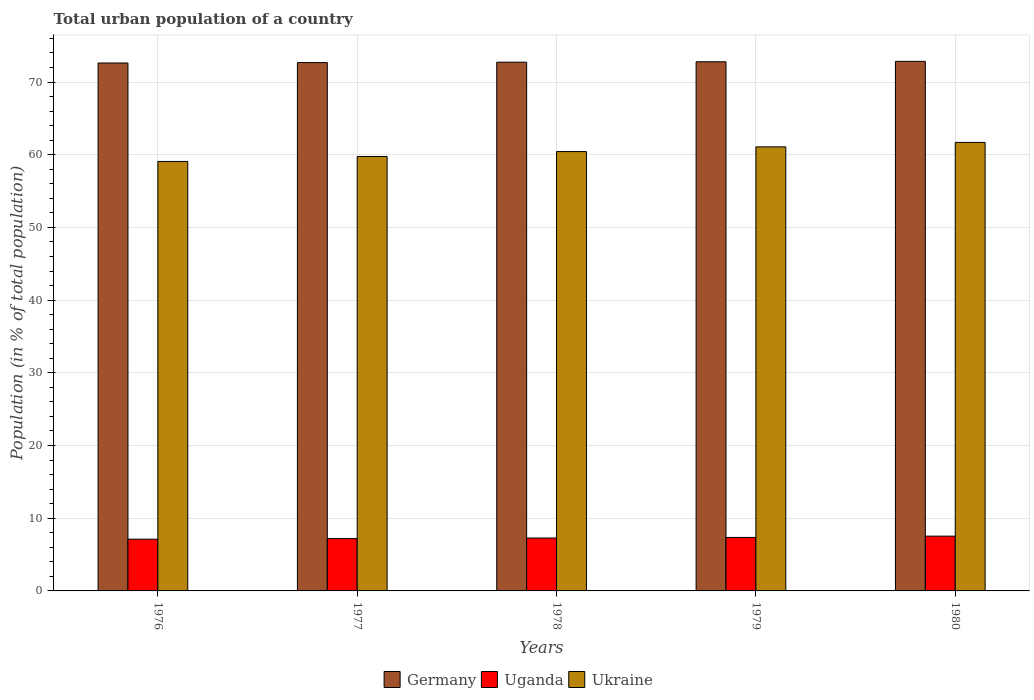How many different coloured bars are there?
Provide a succinct answer. 3. Are the number of bars per tick equal to the number of legend labels?
Your answer should be very brief. Yes. Are the number of bars on each tick of the X-axis equal?
Ensure brevity in your answer.  Yes. How many bars are there on the 2nd tick from the right?
Offer a very short reply. 3. What is the label of the 1st group of bars from the left?
Make the answer very short. 1976. In how many cases, is the number of bars for a given year not equal to the number of legend labels?
Give a very brief answer. 0. What is the urban population in Ukraine in 1977?
Offer a very short reply. 59.76. Across all years, what is the maximum urban population in Uganda?
Offer a terse response. 7.53. Across all years, what is the minimum urban population in Ukraine?
Your answer should be compact. 59.08. In which year was the urban population in Ukraine maximum?
Make the answer very short. 1980. In which year was the urban population in Uganda minimum?
Provide a short and direct response. 1976. What is the total urban population in Uganda in the graph?
Provide a succinct answer. 36.48. What is the difference between the urban population in Ukraine in 1977 and that in 1978?
Keep it short and to the point. -0.68. What is the difference between the urban population in Ukraine in 1977 and the urban population in Germany in 1979?
Offer a very short reply. -13.03. What is the average urban population in Uganda per year?
Provide a succinct answer. 7.3. In the year 1977, what is the difference between the urban population in Uganda and urban population in Germany?
Give a very brief answer. -65.48. What is the ratio of the urban population in Ukraine in 1978 to that in 1979?
Give a very brief answer. 0.99. Is the urban population in Uganda in 1979 less than that in 1980?
Provide a succinct answer. Yes. Is the difference between the urban population in Uganda in 1978 and 1979 greater than the difference between the urban population in Germany in 1978 and 1979?
Your answer should be compact. No. What is the difference between the highest and the second highest urban population in Ukraine?
Provide a succinct answer. 0.61. What is the difference between the highest and the lowest urban population in Germany?
Keep it short and to the point. 0.23. In how many years, is the urban population in Ukraine greater than the average urban population in Ukraine taken over all years?
Provide a succinct answer. 3. Is the sum of the urban population in Ukraine in 1977 and 1980 greater than the maximum urban population in Germany across all years?
Your answer should be very brief. Yes. What does the 1st bar from the left in 1977 represents?
Provide a succinct answer. Germany. What does the 1st bar from the right in 1977 represents?
Give a very brief answer. Ukraine. Is it the case that in every year, the sum of the urban population in Uganda and urban population in Germany is greater than the urban population in Ukraine?
Offer a terse response. Yes. How many bars are there?
Provide a succinct answer. 15. What is the difference between two consecutive major ticks on the Y-axis?
Make the answer very short. 10. Are the values on the major ticks of Y-axis written in scientific E-notation?
Your answer should be compact. No. Does the graph contain any zero values?
Offer a terse response. No. Does the graph contain grids?
Your answer should be compact. Yes. Where does the legend appear in the graph?
Your answer should be very brief. Bottom center. How are the legend labels stacked?
Offer a terse response. Horizontal. What is the title of the graph?
Keep it short and to the point. Total urban population of a country. Does "Qatar" appear as one of the legend labels in the graph?
Give a very brief answer. No. What is the label or title of the Y-axis?
Ensure brevity in your answer.  Population (in % of total population). What is the Population (in % of total population) in Germany in 1976?
Your answer should be very brief. 72.62. What is the Population (in % of total population) of Uganda in 1976?
Provide a short and direct response. 7.12. What is the Population (in % of total population) of Ukraine in 1976?
Ensure brevity in your answer.  59.08. What is the Population (in % of total population) in Germany in 1977?
Provide a short and direct response. 72.67. What is the Population (in % of total population) in Uganda in 1977?
Offer a terse response. 7.2. What is the Population (in % of total population) in Ukraine in 1977?
Your answer should be compact. 59.76. What is the Population (in % of total population) of Germany in 1978?
Your answer should be very brief. 72.73. What is the Population (in % of total population) in Uganda in 1978?
Keep it short and to the point. 7.28. What is the Population (in % of total population) of Ukraine in 1978?
Keep it short and to the point. 60.43. What is the Population (in % of total population) in Germany in 1979?
Offer a terse response. 72.79. What is the Population (in % of total population) of Uganda in 1979?
Keep it short and to the point. 7.36. What is the Population (in % of total population) of Ukraine in 1979?
Your answer should be compact. 61.08. What is the Population (in % of total population) of Germany in 1980?
Provide a short and direct response. 72.84. What is the Population (in % of total population) of Uganda in 1980?
Make the answer very short. 7.53. What is the Population (in % of total population) of Ukraine in 1980?
Give a very brief answer. 61.69. Across all years, what is the maximum Population (in % of total population) in Germany?
Provide a succinct answer. 72.84. Across all years, what is the maximum Population (in % of total population) of Uganda?
Make the answer very short. 7.53. Across all years, what is the maximum Population (in % of total population) of Ukraine?
Make the answer very short. 61.69. Across all years, what is the minimum Population (in % of total population) of Germany?
Ensure brevity in your answer.  72.62. Across all years, what is the minimum Population (in % of total population) in Uganda?
Your answer should be compact. 7.12. Across all years, what is the minimum Population (in % of total population) of Ukraine?
Keep it short and to the point. 59.08. What is the total Population (in % of total population) of Germany in the graph?
Your response must be concise. 363.65. What is the total Population (in % of total population) in Uganda in the graph?
Offer a terse response. 36.48. What is the total Population (in % of total population) in Ukraine in the graph?
Keep it short and to the point. 302.04. What is the difference between the Population (in % of total population) of Germany in 1976 and that in 1977?
Offer a terse response. -0.06. What is the difference between the Population (in % of total population) in Uganda in 1976 and that in 1977?
Offer a terse response. -0.08. What is the difference between the Population (in % of total population) of Ukraine in 1976 and that in 1977?
Offer a terse response. -0.68. What is the difference between the Population (in % of total population) in Germany in 1976 and that in 1978?
Offer a terse response. -0.11. What is the difference between the Population (in % of total population) in Uganda in 1976 and that in 1978?
Offer a very short reply. -0.16. What is the difference between the Population (in % of total population) of Ukraine in 1976 and that in 1978?
Provide a short and direct response. -1.36. What is the difference between the Population (in % of total population) in Germany in 1976 and that in 1979?
Offer a terse response. -0.17. What is the difference between the Population (in % of total population) of Uganda in 1976 and that in 1979?
Keep it short and to the point. -0.24. What is the difference between the Population (in % of total population) of Ukraine in 1976 and that in 1979?
Provide a short and direct response. -2.01. What is the difference between the Population (in % of total population) of Germany in 1976 and that in 1980?
Your answer should be compact. -0.23. What is the difference between the Population (in % of total population) in Uganda in 1976 and that in 1980?
Provide a short and direct response. -0.42. What is the difference between the Population (in % of total population) of Ukraine in 1976 and that in 1980?
Keep it short and to the point. -2.62. What is the difference between the Population (in % of total population) in Germany in 1977 and that in 1978?
Your answer should be very brief. -0.06. What is the difference between the Population (in % of total population) in Uganda in 1977 and that in 1978?
Give a very brief answer. -0.08. What is the difference between the Population (in % of total population) of Ukraine in 1977 and that in 1978?
Your answer should be compact. -0.68. What is the difference between the Population (in % of total population) in Germany in 1977 and that in 1979?
Your response must be concise. -0.11. What is the difference between the Population (in % of total population) of Uganda in 1977 and that in 1979?
Offer a very short reply. -0.16. What is the difference between the Population (in % of total population) in Ukraine in 1977 and that in 1979?
Keep it short and to the point. -1.32. What is the difference between the Population (in % of total population) of Germany in 1977 and that in 1980?
Provide a succinct answer. -0.17. What is the difference between the Population (in % of total population) in Uganda in 1977 and that in 1980?
Provide a short and direct response. -0.34. What is the difference between the Population (in % of total population) in Ukraine in 1977 and that in 1980?
Provide a short and direct response. -1.94. What is the difference between the Population (in % of total population) in Germany in 1978 and that in 1979?
Offer a terse response. -0.06. What is the difference between the Population (in % of total population) in Uganda in 1978 and that in 1979?
Keep it short and to the point. -0.08. What is the difference between the Population (in % of total population) in Ukraine in 1978 and that in 1979?
Your answer should be very brief. -0.65. What is the difference between the Population (in % of total population) in Germany in 1978 and that in 1980?
Provide a succinct answer. -0.11. What is the difference between the Population (in % of total population) in Uganda in 1978 and that in 1980?
Ensure brevity in your answer.  -0.26. What is the difference between the Population (in % of total population) in Ukraine in 1978 and that in 1980?
Your response must be concise. -1.26. What is the difference between the Population (in % of total population) in Germany in 1979 and that in 1980?
Offer a terse response. -0.06. What is the difference between the Population (in % of total population) in Uganda in 1979 and that in 1980?
Your response must be concise. -0.18. What is the difference between the Population (in % of total population) of Ukraine in 1979 and that in 1980?
Your answer should be very brief. -0.61. What is the difference between the Population (in % of total population) in Germany in 1976 and the Population (in % of total population) in Uganda in 1977?
Ensure brevity in your answer.  65.42. What is the difference between the Population (in % of total population) in Germany in 1976 and the Population (in % of total population) in Ukraine in 1977?
Your answer should be compact. 12.86. What is the difference between the Population (in % of total population) of Uganda in 1976 and the Population (in % of total population) of Ukraine in 1977?
Provide a short and direct response. -52.64. What is the difference between the Population (in % of total population) in Germany in 1976 and the Population (in % of total population) in Uganda in 1978?
Offer a terse response. 65.34. What is the difference between the Population (in % of total population) in Germany in 1976 and the Population (in % of total population) in Ukraine in 1978?
Offer a terse response. 12.18. What is the difference between the Population (in % of total population) of Uganda in 1976 and the Population (in % of total population) of Ukraine in 1978?
Provide a short and direct response. -53.32. What is the difference between the Population (in % of total population) in Germany in 1976 and the Population (in % of total population) in Uganda in 1979?
Give a very brief answer. 65.26. What is the difference between the Population (in % of total population) in Germany in 1976 and the Population (in % of total population) in Ukraine in 1979?
Your answer should be very brief. 11.54. What is the difference between the Population (in % of total population) in Uganda in 1976 and the Population (in % of total population) in Ukraine in 1979?
Offer a terse response. -53.96. What is the difference between the Population (in % of total population) of Germany in 1976 and the Population (in % of total population) of Uganda in 1980?
Provide a short and direct response. 65.08. What is the difference between the Population (in % of total population) of Germany in 1976 and the Population (in % of total population) of Ukraine in 1980?
Your answer should be compact. 10.92. What is the difference between the Population (in % of total population) of Uganda in 1976 and the Population (in % of total population) of Ukraine in 1980?
Keep it short and to the point. -54.58. What is the difference between the Population (in % of total population) of Germany in 1977 and the Population (in % of total population) of Uganda in 1978?
Give a very brief answer. 65.4. What is the difference between the Population (in % of total population) in Germany in 1977 and the Population (in % of total population) in Ukraine in 1978?
Make the answer very short. 12.24. What is the difference between the Population (in % of total population) of Uganda in 1977 and the Population (in % of total population) of Ukraine in 1978?
Provide a succinct answer. -53.24. What is the difference between the Population (in % of total population) of Germany in 1977 and the Population (in % of total population) of Uganda in 1979?
Offer a terse response. 65.32. What is the difference between the Population (in % of total population) of Germany in 1977 and the Population (in % of total population) of Ukraine in 1979?
Ensure brevity in your answer.  11.59. What is the difference between the Population (in % of total population) in Uganda in 1977 and the Population (in % of total population) in Ukraine in 1979?
Make the answer very short. -53.88. What is the difference between the Population (in % of total population) of Germany in 1977 and the Population (in % of total population) of Uganda in 1980?
Give a very brief answer. 65.14. What is the difference between the Population (in % of total population) in Germany in 1977 and the Population (in % of total population) in Ukraine in 1980?
Ensure brevity in your answer.  10.98. What is the difference between the Population (in % of total population) of Uganda in 1977 and the Population (in % of total population) of Ukraine in 1980?
Make the answer very short. -54.5. What is the difference between the Population (in % of total population) of Germany in 1978 and the Population (in % of total population) of Uganda in 1979?
Offer a terse response. 65.37. What is the difference between the Population (in % of total population) in Germany in 1978 and the Population (in % of total population) in Ukraine in 1979?
Provide a short and direct response. 11.65. What is the difference between the Population (in % of total population) of Uganda in 1978 and the Population (in % of total population) of Ukraine in 1979?
Your response must be concise. -53.8. What is the difference between the Population (in % of total population) in Germany in 1978 and the Population (in % of total population) in Uganda in 1980?
Provide a succinct answer. 65.2. What is the difference between the Population (in % of total population) of Germany in 1978 and the Population (in % of total population) of Ukraine in 1980?
Give a very brief answer. 11.04. What is the difference between the Population (in % of total population) of Uganda in 1978 and the Population (in % of total population) of Ukraine in 1980?
Provide a succinct answer. -54.42. What is the difference between the Population (in % of total population) of Germany in 1979 and the Population (in % of total population) of Uganda in 1980?
Your answer should be very brief. 65.25. What is the difference between the Population (in % of total population) of Germany in 1979 and the Population (in % of total population) of Ukraine in 1980?
Make the answer very short. 11.09. What is the difference between the Population (in % of total population) of Uganda in 1979 and the Population (in % of total population) of Ukraine in 1980?
Your response must be concise. -54.34. What is the average Population (in % of total population) in Germany per year?
Offer a very short reply. 72.73. What is the average Population (in % of total population) in Uganda per year?
Offer a very short reply. 7.3. What is the average Population (in % of total population) of Ukraine per year?
Ensure brevity in your answer.  60.41. In the year 1976, what is the difference between the Population (in % of total population) of Germany and Population (in % of total population) of Uganda?
Your answer should be very brief. 65.5. In the year 1976, what is the difference between the Population (in % of total population) of Germany and Population (in % of total population) of Ukraine?
Your answer should be very brief. 13.54. In the year 1976, what is the difference between the Population (in % of total population) in Uganda and Population (in % of total population) in Ukraine?
Your answer should be compact. -51.96. In the year 1977, what is the difference between the Population (in % of total population) in Germany and Population (in % of total population) in Uganda?
Make the answer very short. 65.48. In the year 1977, what is the difference between the Population (in % of total population) of Germany and Population (in % of total population) of Ukraine?
Your answer should be very brief. 12.92. In the year 1977, what is the difference between the Population (in % of total population) of Uganda and Population (in % of total population) of Ukraine?
Give a very brief answer. -52.56. In the year 1978, what is the difference between the Population (in % of total population) of Germany and Population (in % of total population) of Uganda?
Provide a short and direct response. 65.45. In the year 1978, what is the difference between the Population (in % of total population) in Germany and Population (in % of total population) in Ukraine?
Make the answer very short. 12.3. In the year 1978, what is the difference between the Population (in % of total population) in Uganda and Population (in % of total population) in Ukraine?
Ensure brevity in your answer.  -53.16. In the year 1979, what is the difference between the Population (in % of total population) in Germany and Population (in % of total population) in Uganda?
Ensure brevity in your answer.  65.43. In the year 1979, what is the difference between the Population (in % of total population) of Germany and Population (in % of total population) of Ukraine?
Your response must be concise. 11.71. In the year 1979, what is the difference between the Population (in % of total population) in Uganda and Population (in % of total population) in Ukraine?
Your answer should be very brief. -53.73. In the year 1980, what is the difference between the Population (in % of total population) of Germany and Population (in % of total population) of Uganda?
Offer a very short reply. 65.31. In the year 1980, what is the difference between the Population (in % of total population) in Germany and Population (in % of total population) in Ukraine?
Offer a very short reply. 11.15. In the year 1980, what is the difference between the Population (in % of total population) in Uganda and Population (in % of total population) in Ukraine?
Provide a short and direct response. -54.16. What is the ratio of the Population (in % of total population) of Uganda in 1976 to that in 1977?
Ensure brevity in your answer.  0.99. What is the ratio of the Population (in % of total population) of Ukraine in 1976 to that in 1977?
Offer a very short reply. 0.99. What is the ratio of the Population (in % of total population) in Uganda in 1976 to that in 1978?
Keep it short and to the point. 0.98. What is the ratio of the Population (in % of total population) in Ukraine in 1976 to that in 1978?
Give a very brief answer. 0.98. What is the ratio of the Population (in % of total population) in Uganda in 1976 to that in 1979?
Provide a succinct answer. 0.97. What is the ratio of the Population (in % of total population) of Ukraine in 1976 to that in 1979?
Keep it short and to the point. 0.97. What is the ratio of the Population (in % of total population) of Germany in 1976 to that in 1980?
Your response must be concise. 1. What is the ratio of the Population (in % of total population) in Uganda in 1976 to that in 1980?
Offer a terse response. 0.94. What is the ratio of the Population (in % of total population) in Ukraine in 1976 to that in 1980?
Make the answer very short. 0.96. What is the ratio of the Population (in % of total population) of Germany in 1977 to that in 1978?
Your response must be concise. 1. What is the ratio of the Population (in % of total population) in Uganda in 1977 to that in 1978?
Your answer should be very brief. 0.99. What is the ratio of the Population (in % of total population) in Germany in 1977 to that in 1979?
Give a very brief answer. 1. What is the ratio of the Population (in % of total population) of Uganda in 1977 to that in 1979?
Your answer should be very brief. 0.98. What is the ratio of the Population (in % of total population) of Ukraine in 1977 to that in 1979?
Your answer should be very brief. 0.98. What is the ratio of the Population (in % of total population) in Germany in 1977 to that in 1980?
Your answer should be compact. 1. What is the ratio of the Population (in % of total population) in Uganda in 1977 to that in 1980?
Make the answer very short. 0.96. What is the ratio of the Population (in % of total population) in Ukraine in 1977 to that in 1980?
Provide a succinct answer. 0.97. What is the ratio of the Population (in % of total population) of Germany in 1978 to that in 1979?
Offer a very short reply. 1. What is the ratio of the Population (in % of total population) in Uganda in 1978 to that in 1979?
Keep it short and to the point. 0.99. What is the ratio of the Population (in % of total population) in Uganda in 1978 to that in 1980?
Make the answer very short. 0.97. What is the ratio of the Population (in % of total population) of Ukraine in 1978 to that in 1980?
Ensure brevity in your answer.  0.98. What is the ratio of the Population (in % of total population) in Uganda in 1979 to that in 1980?
Offer a terse response. 0.98. What is the ratio of the Population (in % of total population) in Ukraine in 1979 to that in 1980?
Make the answer very short. 0.99. What is the difference between the highest and the second highest Population (in % of total population) in Germany?
Ensure brevity in your answer.  0.06. What is the difference between the highest and the second highest Population (in % of total population) of Uganda?
Provide a short and direct response. 0.18. What is the difference between the highest and the second highest Population (in % of total population) of Ukraine?
Your response must be concise. 0.61. What is the difference between the highest and the lowest Population (in % of total population) of Germany?
Offer a very short reply. 0.23. What is the difference between the highest and the lowest Population (in % of total population) in Uganda?
Your answer should be compact. 0.42. What is the difference between the highest and the lowest Population (in % of total population) of Ukraine?
Provide a short and direct response. 2.62. 